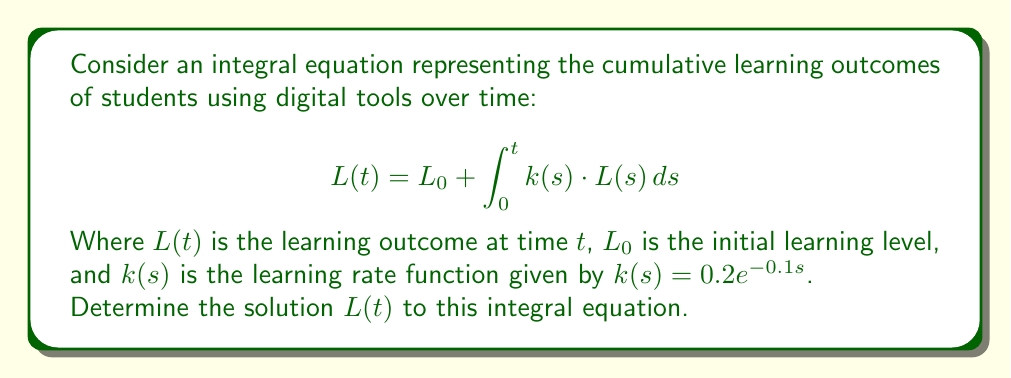Provide a solution to this math problem. To solve this integral equation, we'll follow these steps:

1) First, we recognize this as a Volterra integral equation of the second kind.

2) We can solve this using the method of Laplace transforms. Let's denote the Laplace transform of $L(t)$ as $\mathcal{L}\{L(t)\} = \bar{L}(p)$.

3) Taking the Laplace transform of both sides:

   $$\mathcal{L}\{L(t)\} = \mathcal{L}\{L_0\} + \mathcal{L}\{\int_0^t k(s) \cdot L(s) \, ds\}$$

4) Using the properties of Laplace transforms:

   $$\bar{L}(p) = \frac{L_0}{p} + \mathcal{L}\{k(t)\} \cdot \bar{L}(p)$$

5) We need to find $\mathcal{L}\{k(t)\}$:

   $$\mathcal{L}\{k(t)\} = \mathcal{L}\{0.2e^{-0.1t}\} = \frac{0.2}{p + 0.1}$$

6) Substituting this back:

   $$\bar{L}(p) = \frac{L_0}{p} + \frac{0.2}{p + 0.1} \cdot \bar{L}(p)$$

7) Solving for $\bar{L}(p)$:

   $$\bar{L}(p) = \frac{L_0}{p} \cdot \frac{1}{1 - \frac{0.2}{p + 0.1}} = \frac{L_0(p + 0.1)}{p(p + 0.1) - 0.2p}$$

8) Simplifying:

   $$\bar{L}(p) = \frac{L_0(p + 0.1)}{p^2 + 0.1p - 0.2p} = \frac{L_0(p + 0.1)}{p^2 - 0.1p}$$

9) To find $L(t)$, we need to take the inverse Laplace transform. This can be done by partial fraction decomposition:

   $$\frac{L_0(p + 0.1)}{p^2 - 0.1p} = \frac{A}{p} + \frac{B}{p - 0.1}$$

   Where $A = L_0$ and $B = L_0$

10) Taking the inverse Laplace transform:

    $$L(t) = L_0 + L_0e^{0.1t}$$

This is the solution to the integral equation.
Answer: $L(t) = L_0(1 + e^{0.1t})$ 